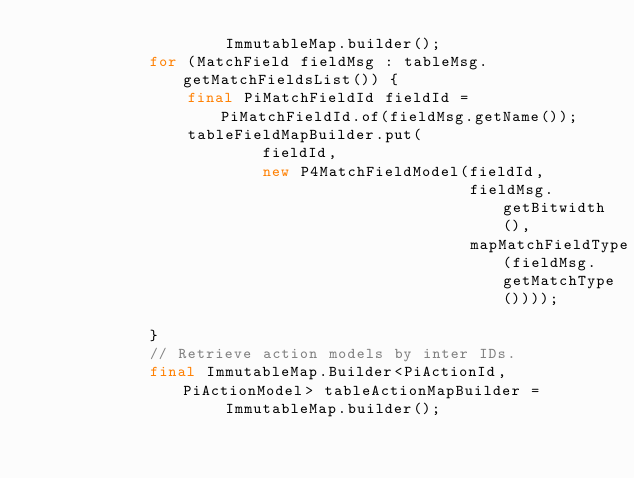<code> <loc_0><loc_0><loc_500><loc_500><_Java_>                    ImmutableMap.builder();
            for (MatchField fieldMsg : tableMsg.getMatchFieldsList()) {
                final PiMatchFieldId fieldId = PiMatchFieldId.of(fieldMsg.getName());
                tableFieldMapBuilder.put(
                        fieldId,
                        new P4MatchFieldModel(fieldId,
                                              fieldMsg.getBitwidth(),
                                              mapMatchFieldType(fieldMsg.getMatchType())));

            }
            // Retrieve action models by inter IDs.
            final ImmutableMap.Builder<PiActionId, PiActionModel> tableActionMapBuilder =
                    ImmutableMap.builder();</code> 